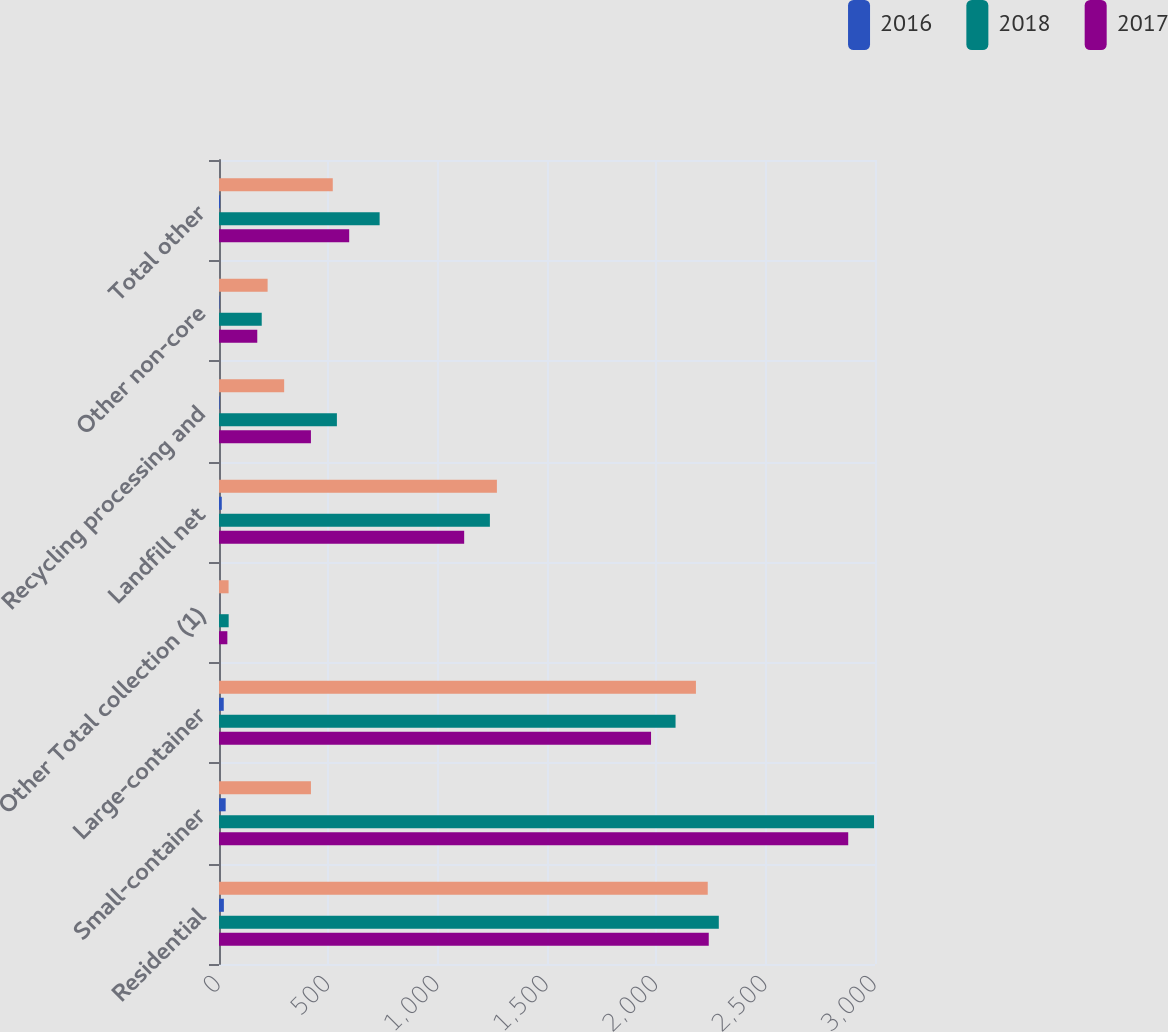<chart> <loc_0><loc_0><loc_500><loc_500><stacked_bar_chart><ecel><fcel>Residential<fcel>Small-container<fcel>Large-container<fcel>Other Total collection (1)<fcel>Landfill net<fcel>Recycling processing and<fcel>Other non-core<fcel>Total other<nl><fcel>nan<fcel>2235.1<fcel>420.4<fcel>2181.1<fcel>43.8<fcel>1270.9<fcel>298<fcel>222.3<fcel>520.3<nl><fcel>2016<fcel>22.3<fcel>30.5<fcel>21.7<fcel>0.4<fcel>12.7<fcel>3<fcel>2.1<fcel>5.1<nl><fcel>2018<fcel>2285.7<fcel>2995.6<fcel>2087.9<fcel>44.2<fcel>1238.8<fcel>539.2<fcel>195.4<fcel>734.6<nl><fcel>2017<fcel>2239.7<fcel>2877.5<fcel>1975.8<fcel>38.2<fcel>1121.2<fcel>420.4<fcel>175<fcel>595.4<nl></chart> 